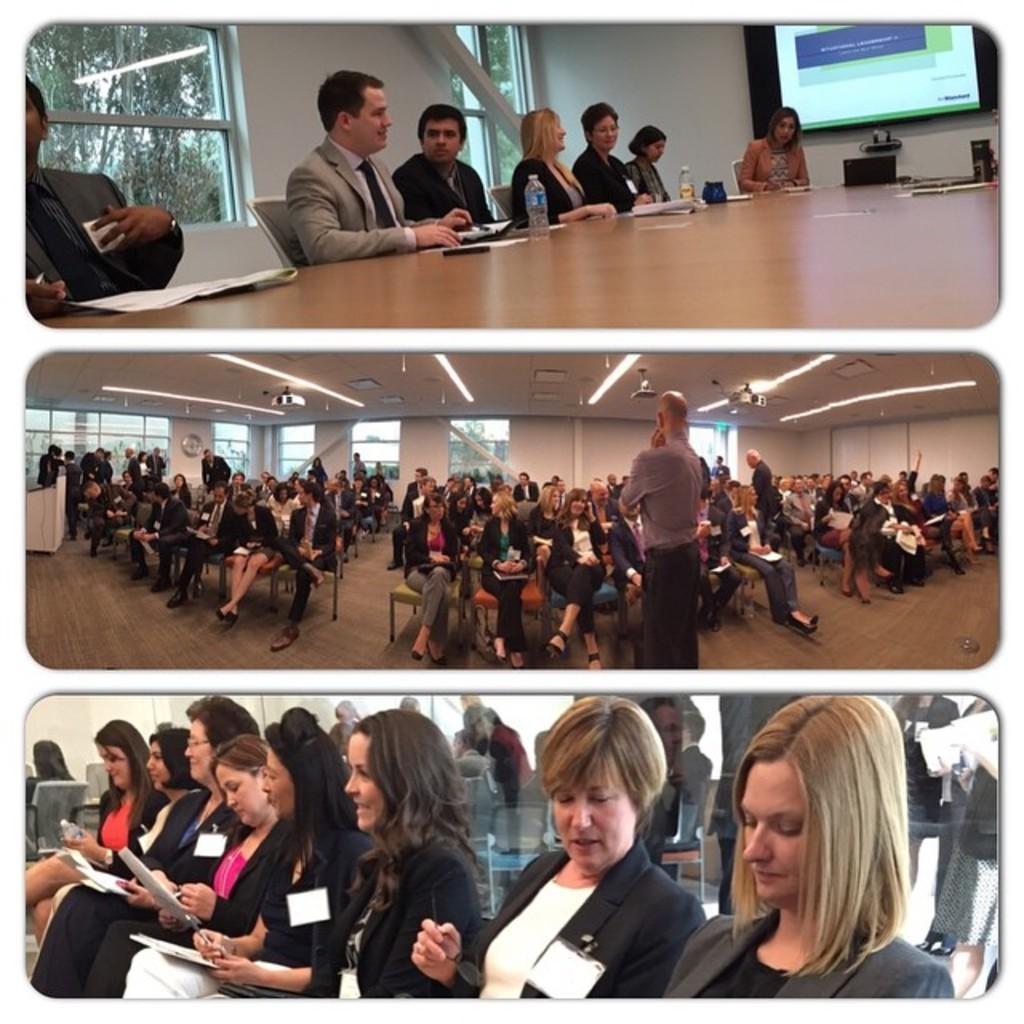How would you summarize this image in a sentence or two? In this image we can see a collage pictures, in those pictures there are a few people, some of them are sitting on the chairs, some people are writing on the papers, there are papers, bottles on the table, there are windows, there is a screen with text on it, there are trees, also we can see the walls. 